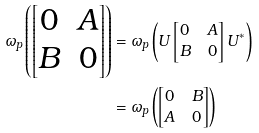<formula> <loc_0><loc_0><loc_500><loc_500>\omega _ { p } \left ( \begin{bmatrix} 0 & A \\ B & 0 \end{bmatrix} \right ) & = \omega _ { p } \left ( U \begin{bmatrix} 0 & A \\ B & 0 \end{bmatrix} U ^ { \ast } \right ) \\ & = \omega _ { p } \left ( \begin{bmatrix} 0 & B \\ A & 0 \end{bmatrix} \right )</formula> 